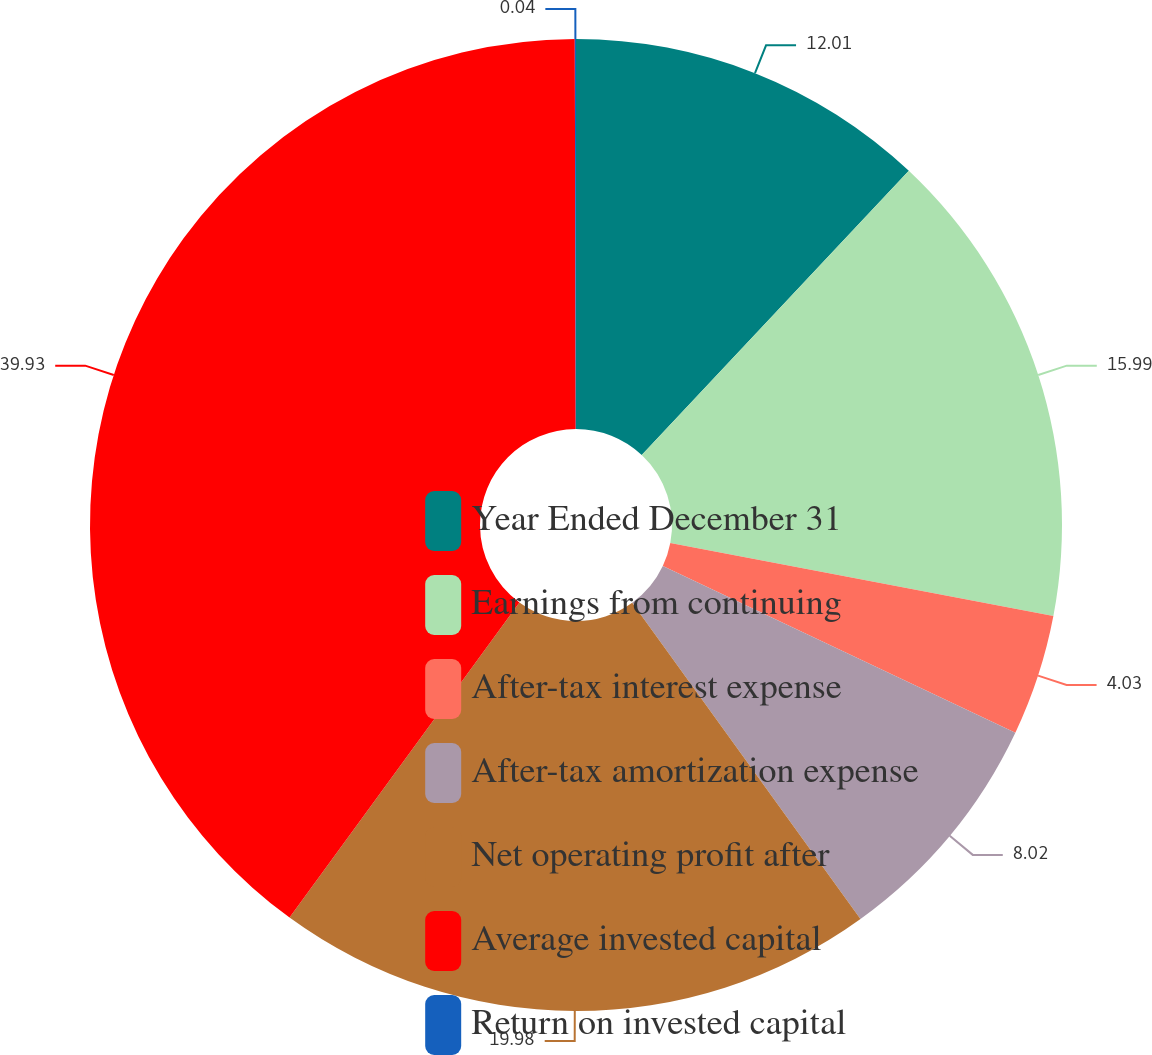Convert chart. <chart><loc_0><loc_0><loc_500><loc_500><pie_chart><fcel>Year Ended December 31<fcel>Earnings from continuing<fcel>After-tax interest expense<fcel>After-tax amortization expense<fcel>Net operating profit after<fcel>Average invested capital<fcel>Return on invested capital<nl><fcel>12.01%<fcel>16.0%<fcel>4.03%<fcel>8.02%<fcel>19.99%<fcel>39.94%<fcel>0.04%<nl></chart> 